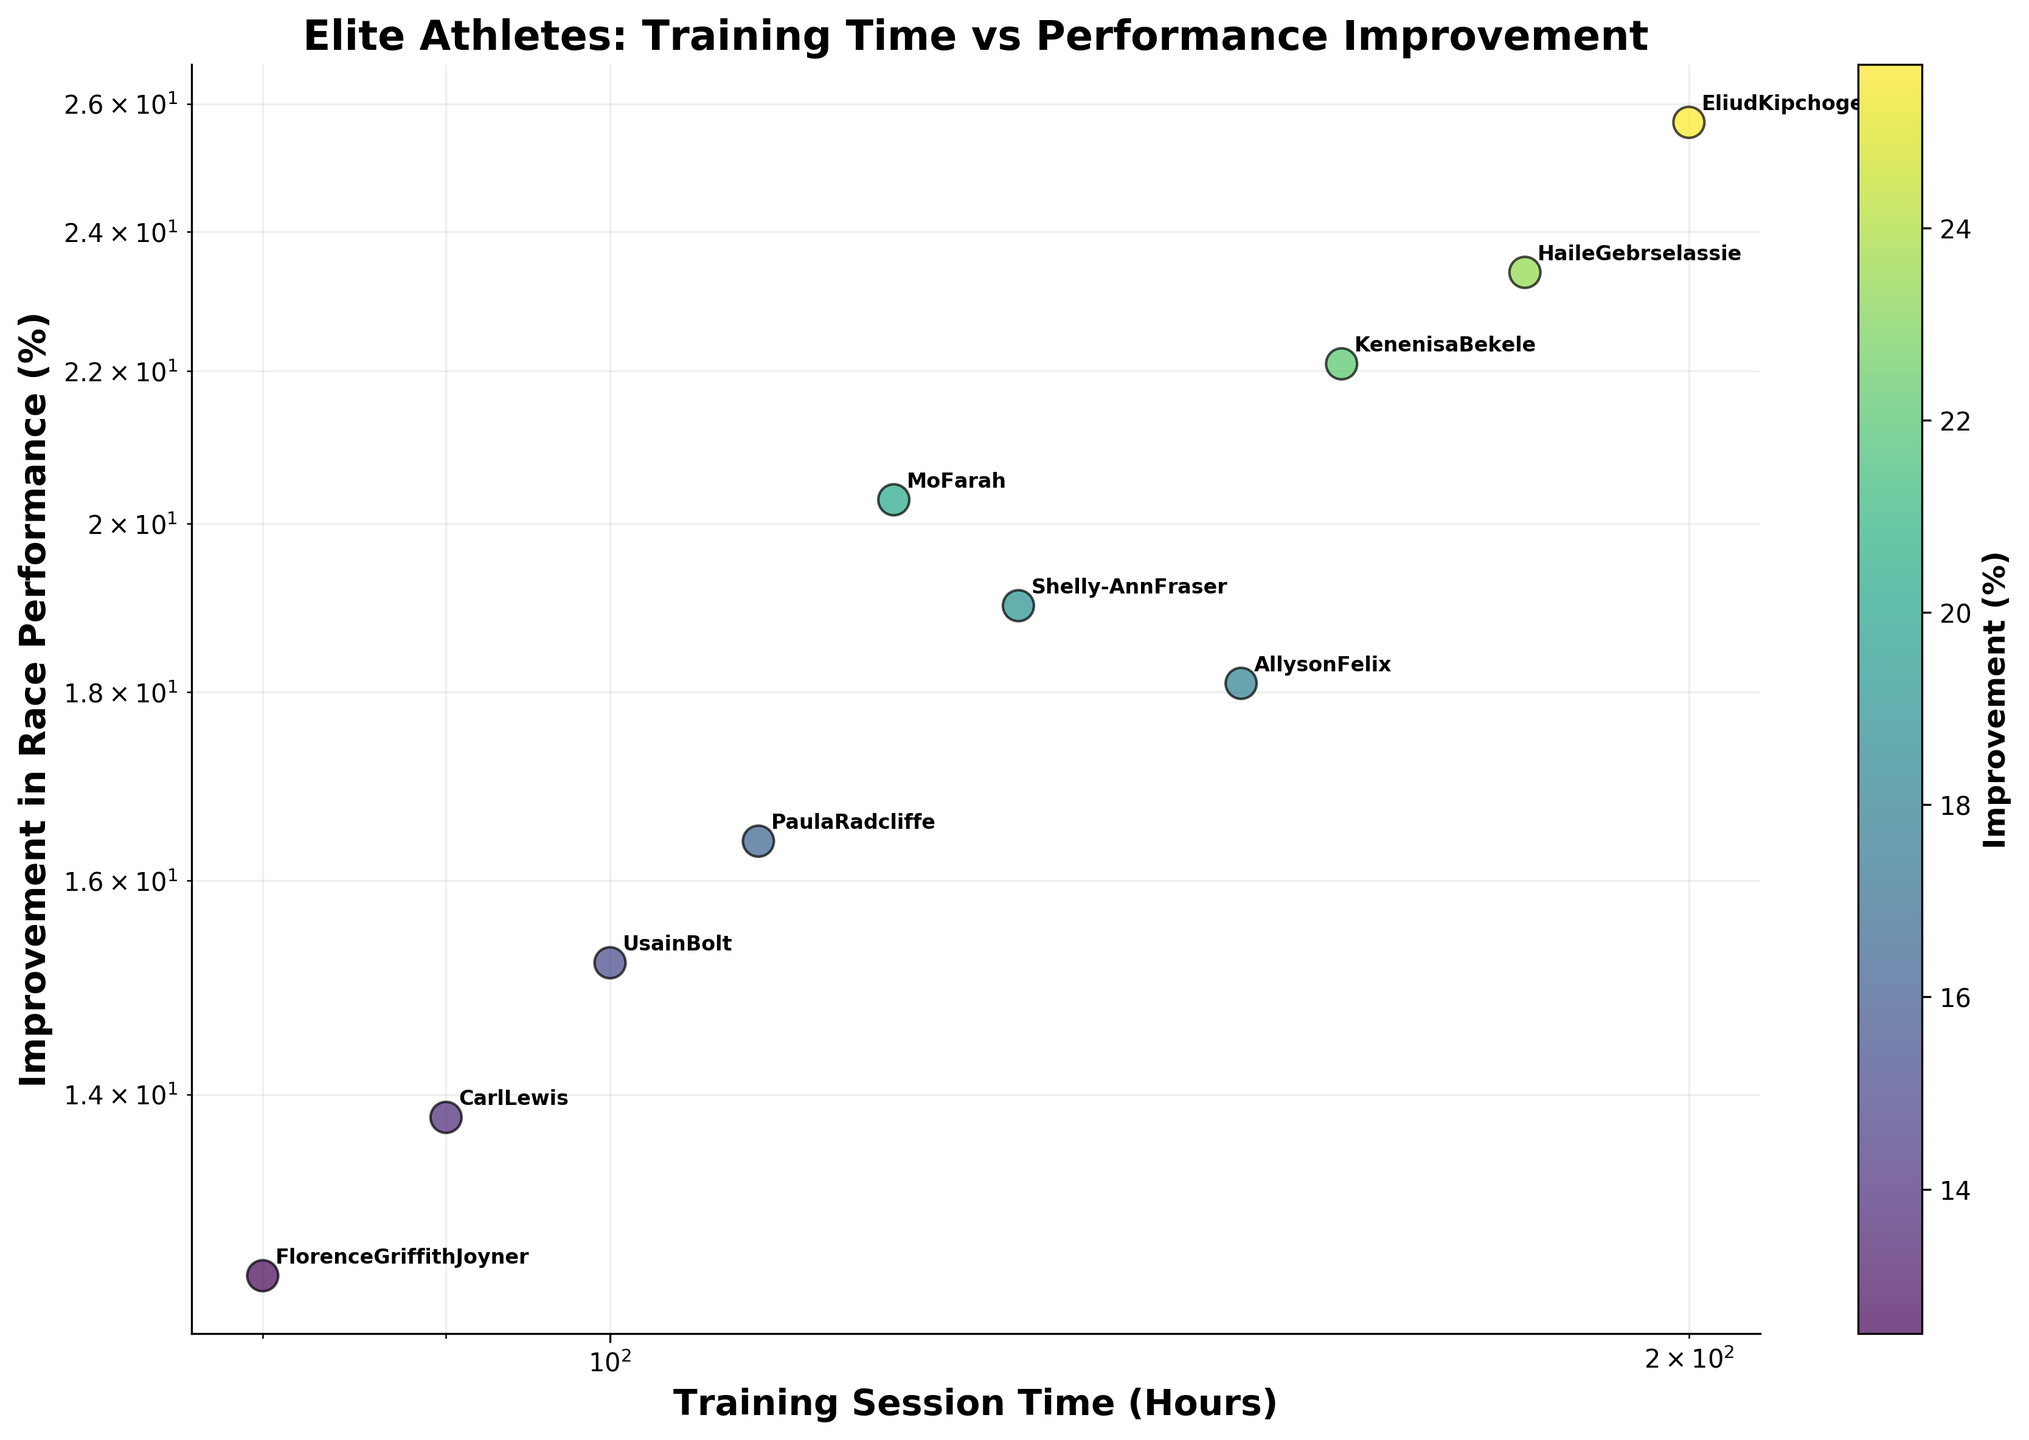What's the title of the plot? The title is displayed at the top of the plot that describes the figure's content.
Answer: Elite Athletes: Training Time vs Performance Improvement What are the x and y axes representing? The labels on the x-axis and y-axis indicate the variables being plotted.
Answer: The x-axis represents "Training Session Time (Hours)" and the y-axis represents "Improvement in Race Performance (%)" How many data points are there in the scatter plot? Each data point corresponds to an athlete's training time and improvement in performance. Counting them will give the total number of data points.
Answer: 10 Which athlete has the highest improvement in race performance and what is that percentage? By finding the data point that is highest on the y-axis, we can identify the athlete with the highest improvement.
Answer: Eliud Kipchoge with 25.7% Compare the training session times of Allyson Felix and Carl Lewis, which one has trained more hours? By looking at the x-axis values for both athletes, we can compare the training session times.
Answer: Allyson Felix How does the improvement in race performance of Paula Radcliffe compare to Florence Griffith-Joyner? By comparing the y-axis values for both athletes, we can determine who has a higher improvement percentage.
Answer: Paula Radcliffe What's the average improvement in race performance among all the athletes? Sum all the percentages of improvement and divide by the total number of athletes. (15.2 + 18.1 + 20.3 + 25.7 + 23.4 + 12.5 + 13.8 + 19.0 + 22.1 + 16.4)/10
Answer: 18.65% Which athlete shows the least improvement in race performance and what is their training session time? Find the data point that is lowest on the y-axis, then check its training session time on the x-axis.
Answer: Florence Griffith-Joyner with 80 hours Is there an apparent relationship between the training session time and improvement in race performance? Observing the overall distribution of the points on the plot, particularly the trend in log-log scale, can reveal if more training hours tend to result in higher performance improvement.
Answer: Yes, there is a positive relationship What is the improvement in race performance percentage for Shelly-Ann Fraser and how many hours did she train? Locate Shelly-Ann Fraser's data point on the scatter plot and read off the values on the x and y axes.
Answer: 19.0% improvement and 130 hours of training 